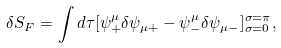Convert formula to latex. <formula><loc_0><loc_0><loc_500><loc_500>\delta S _ { F } = \int d \tau [ \psi ^ { \mu } _ { + } \delta \psi _ { \mu + } - \psi ^ { \mu } _ { - } \delta \psi _ { \mu - } ] ^ { \sigma = \pi } _ { \sigma = 0 } ,</formula> 